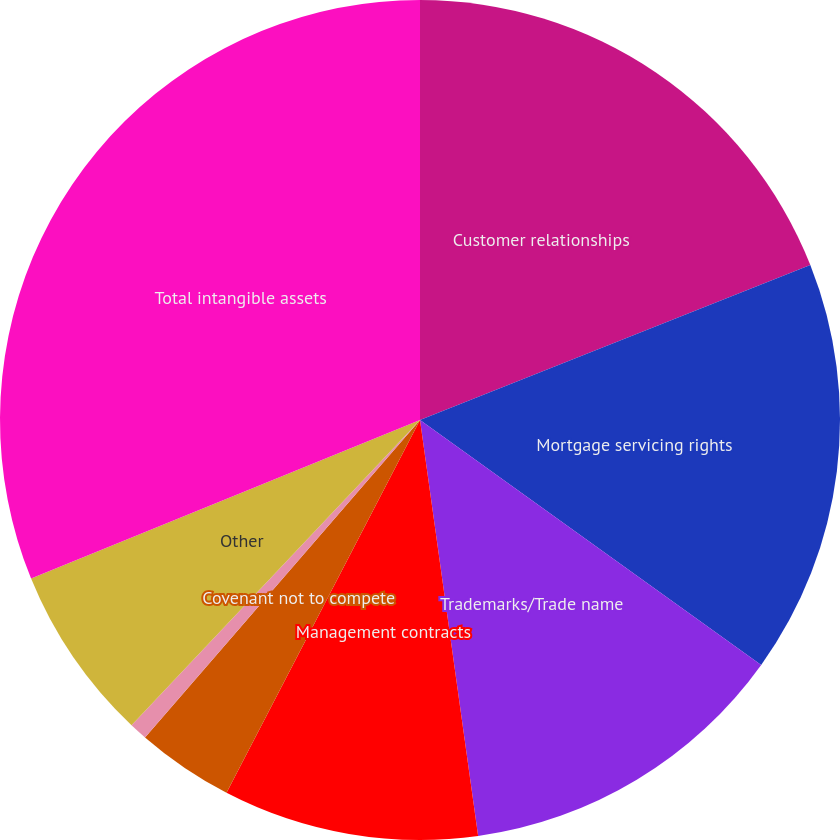Convert chart. <chart><loc_0><loc_0><loc_500><loc_500><pie_chart><fcel>Customer relationships<fcel>Mortgage servicing rights<fcel>Trademarks/Trade name<fcel>Management contracts<fcel>Covenant not to compete<fcel>Backlog and incentive fees<fcel>Other<fcel>Total intangible assets<nl><fcel>18.98%<fcel>15.93%<fcel>12.88%<fcel>9.83%<fcel>3.74%<fcel>0.69%<fcel>6.79%<fcel>31.16%<nl></chart> 